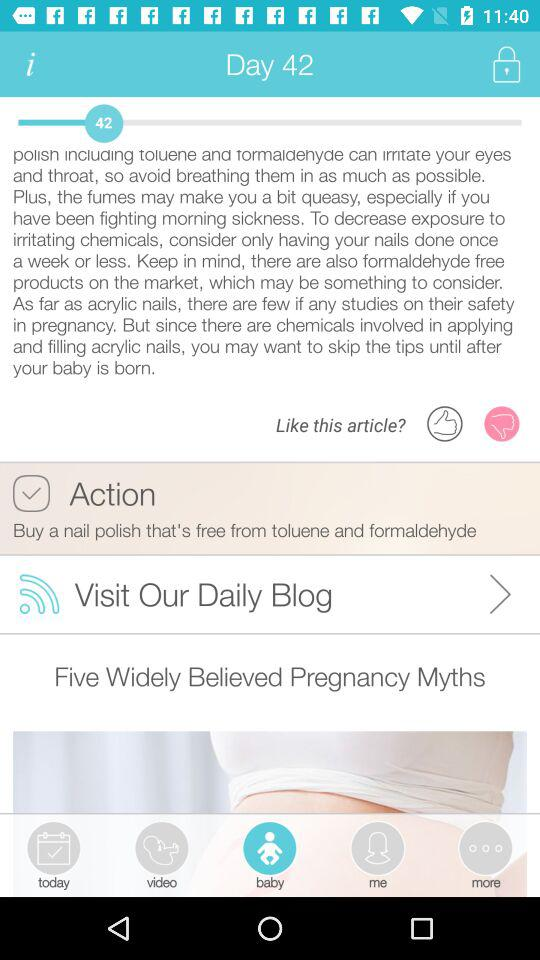What day of the article is this? The day of the article is 42. 